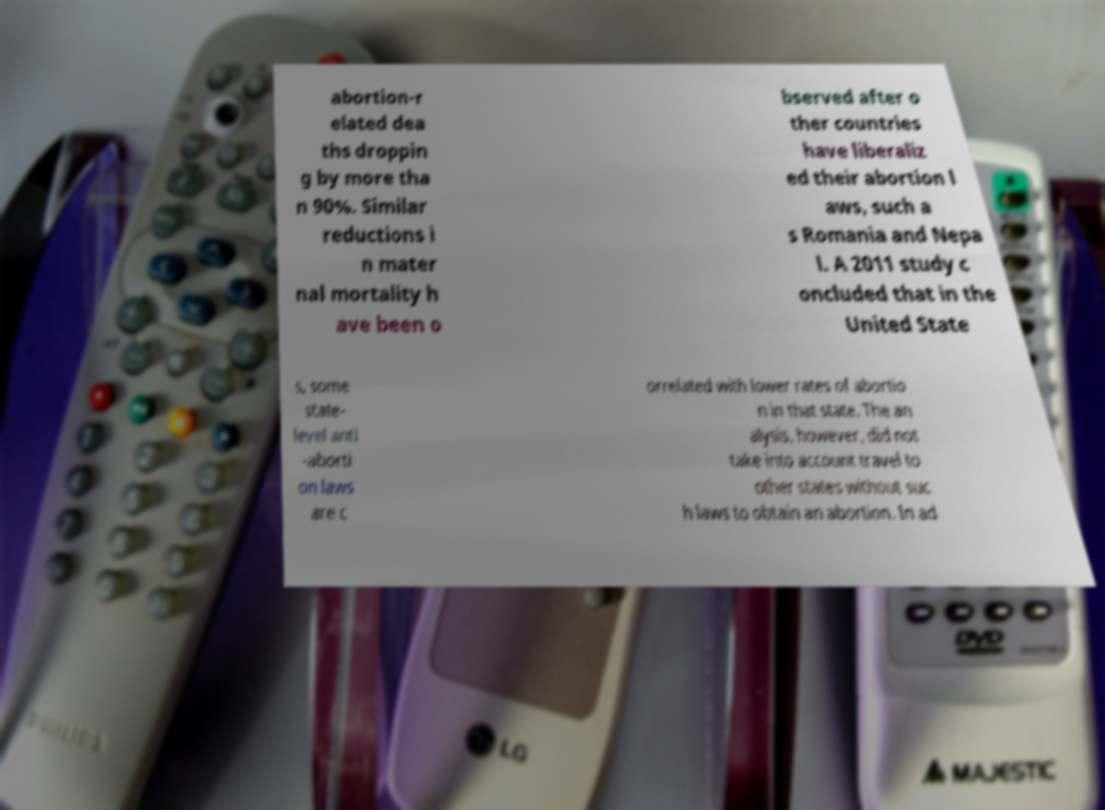Please read and relay the text visible in this image. What does it say? abortion-r elated dea ths droppin g by more tha n 90%. Similar reductions i n mater nal mortality h ave been o bserved after o ther countries have liberaliz ed their abortion l aws, such a s Romania and Nepa l. A 2011 study c oncluded that in the United State s, some state- level anti -aborti on laws are c orrelated with lower rates of abortio n in that state. The an alysis, however, did not take into account travel to other states without suc h laws to obtain an abortion. In ad 